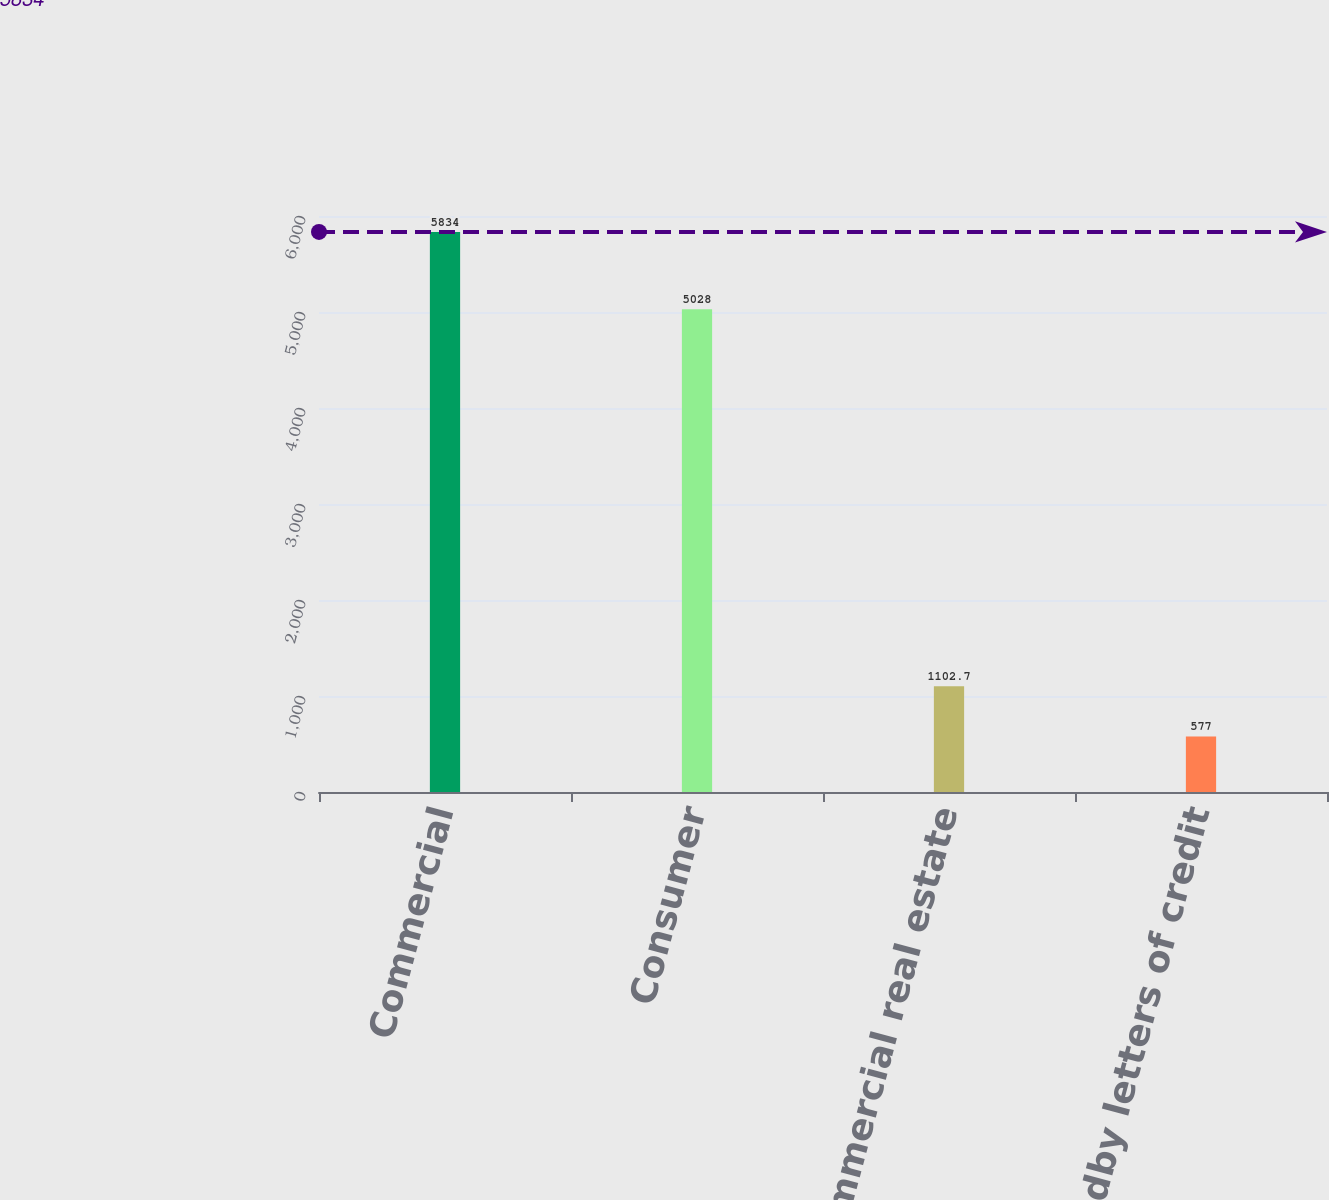Convert chart to OTSL. <chart><loc_0><loc_0><loc_500><loc_500><bar_chart><fcel>Commercial<fcel>Consumer<fcel>Commercial real estate<fcel>Standby letters of credit<nl><fcel>5834<fcel>5028<fcel>1102.7<fcel>577<nl></chart> 